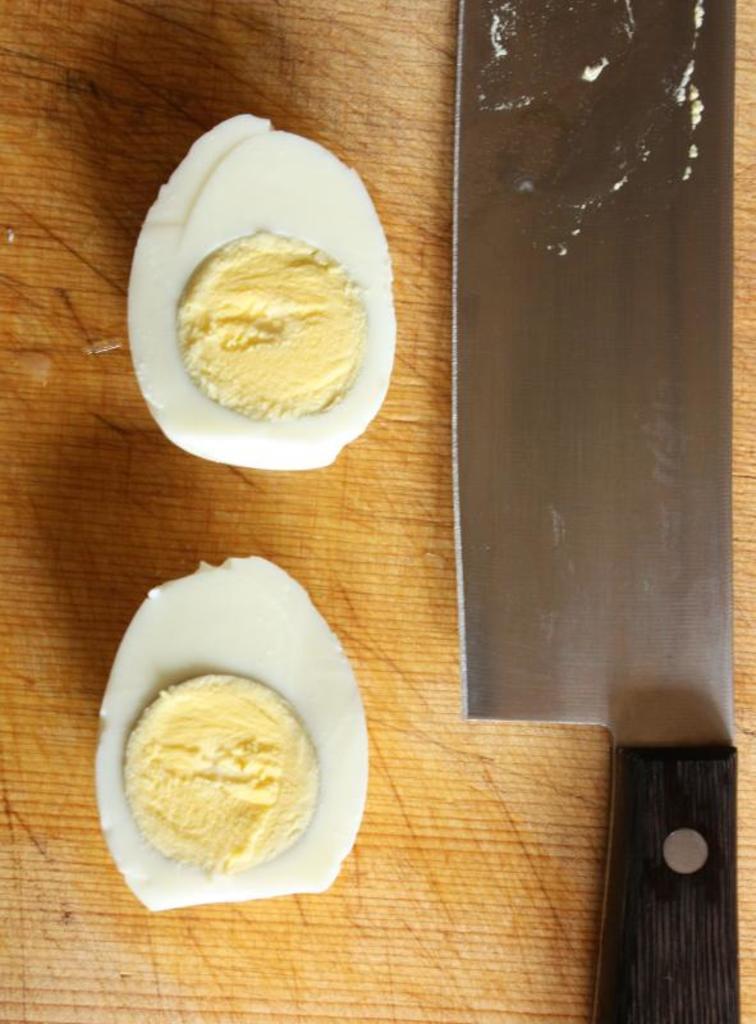Please provide a concise description of this image. In this picture we can see boiled egg slices and a knife on the wooden surface. 